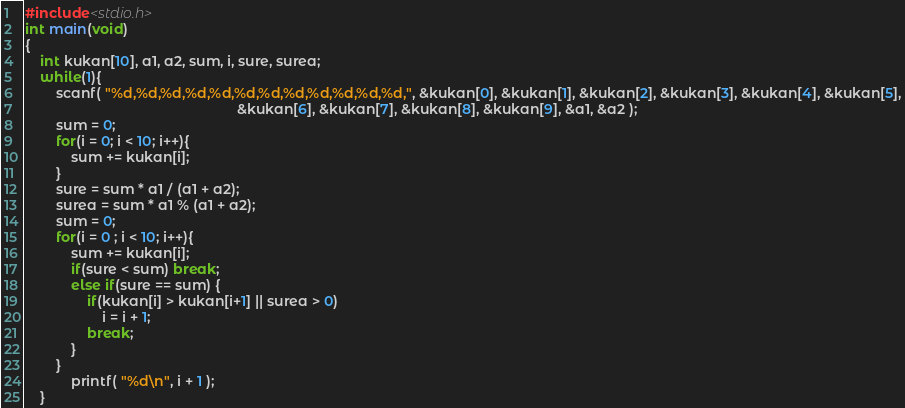<code> <loc_0><loc_0><loc_500><loc_500><_C_>#include<stdio.h>
int main(void)
{
	int kukan[10], a1, a2, sum, i, sure, surea;
	while(1){
		scanf( "%d,%d,%d,%d,%d,%d,%d,%d,%d,%d,%d,%d,", &kukan[0], &kukan[1], &kukan[2], &kukan[3], &kukan[4], &kukan[5],
		                                               &kukan[6], &kukan[7], &kukan[8], &kukan[9], &a1, &a2 );
		sum = 0;
		for(i = 0; i < 10; i++){
			sum += kukan[i];
		}
		sure = sum * a1 / (a1 + a2);
		surea = sum * a1 % (a1 + a2);
		sum = 0;
		for(i = 0 ; i < 10; i++){
			sum += kukan[i];
			if(sure < sum) break;
			else if(sure == sum) {
				if(kukan[i] > kukan[i+1] || surea > 0)
					i = i + 1;
				break;
			}
		}
			printf( "%d\n", i + 1 );
	}</code> 